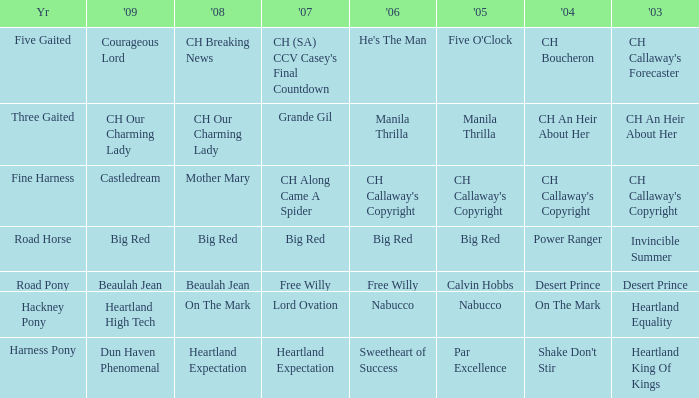What is the 2008 for the 2009 ch our charming lady? CH Our Charming Lady. 